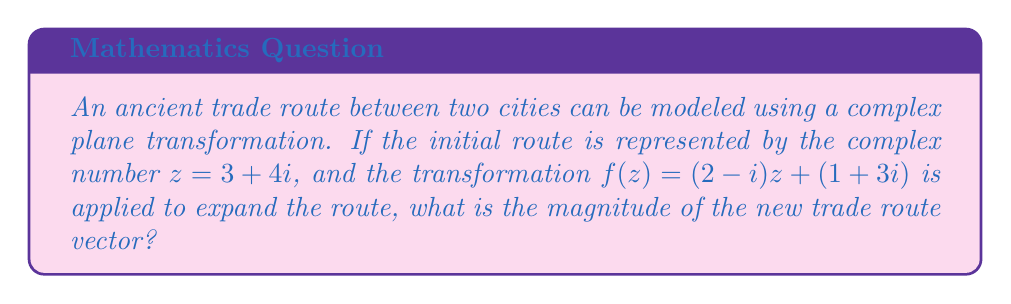Teach me how to tackle this problem. Let's approach this step-by-step:

1) We start with the initial trade route vector $z = 3 + 4i$.

2) The transformation function is $f(z) = (2-i)z + (1+3i)$.

3) Let's apply the transformation:
   $f(z) = (2-i)(3+4i) + (1+3i)$

4) First, let's multiply $(2-i)(3+4i)$:
   $(2-i)(3+4i) = 6 + 8i - 3i - 4i^2$
   $= 6 + 5i + 4$ (since $i^2 = -1$)
   $= 10 + 5i$

5) Now, we can complete the transformation:
   $f(z) = (10 + 5i) + (1 + 3i)$
   $= 11 + 8i$

6) This complex number $11 + 8i$ represents our new trade route vector.

7) To find the magnitude of this vector, we use the formula $|a + bi| = \sqrt{a^2 + b^2}$:

   $|11 + 8i| = \sqrt{11^2 + 8^2}$
   $= \sqrt{121 + 64}$
   $= \sqrt{185}$

Therefore, the magnitude of the new trade route vector is $\sqrt{185}$.
Answer: $\sqrt{185}$ 